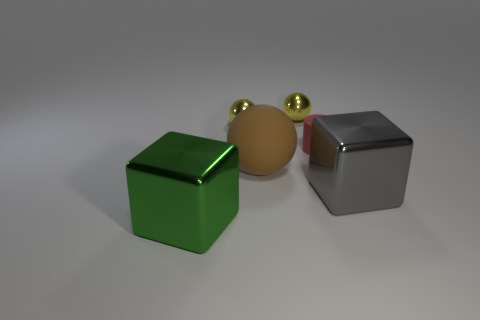There is another large thing that is the same shape as the gray thing; what is its material?
Give a very brief answer. Metal. How many other things are the same size as the green metallic thing?
Offer a very short reply. 2. What material is the gray cube?
Ensure brevity in your answer.  Metal. Are there more spheres that are on the right side of the big rubber thing than tiny purple cylinders?
Offer a terse response. Yes. Are there any large gray metal cubes?
Offer a very short reply. Yes. What number of other things are there of the same shape as the brown thing?
Ensure brevity in your answer.  2. There is a small shiny object that is to the right of the large brown object; is it the same color as the tiny object that is on the left side of the big ball?
Your response must be concise. Yes. There is a cube that is on the left side of the big metallic cube that is to the right of the ball that is on the left side of the large matte thing; what is its size?
Ensure brevity in your answer.  Large. What is the shape of the shiny object that is behind the large brown thing and right of the brown matte sphere?
Give a very brief answer. Sphere. Is the number of tiny metal things that are in front of the gray metal block the same as the number of tiny yellow objects on the right side of the large green block?
Provide a succinct answer. No. 